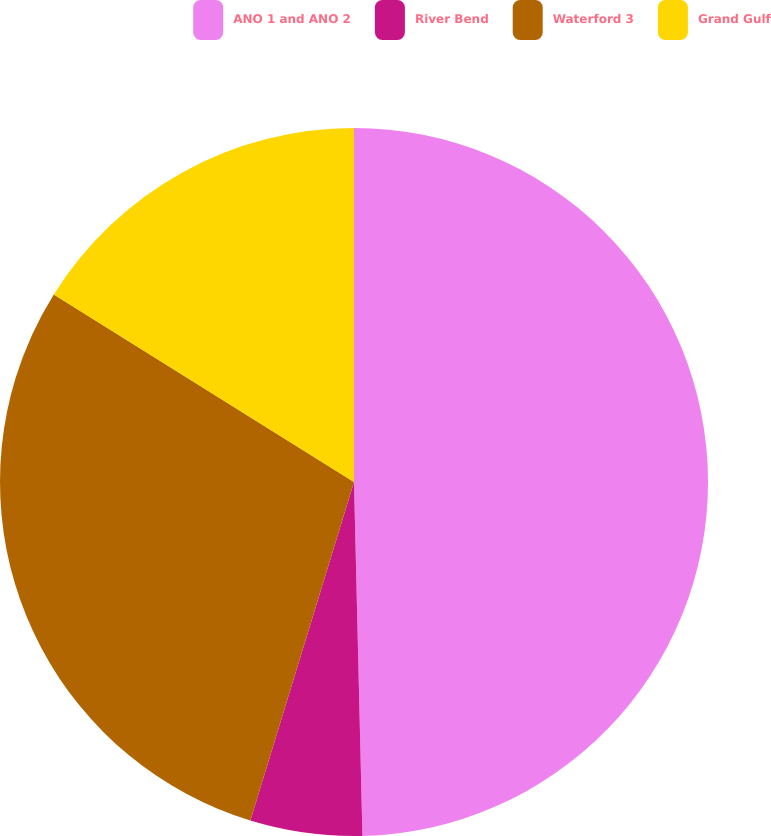<chart> <loc_0><loc_0><loc_500><loc_500><pie_chart><fcel>ANO 1 and ANO 2<fcel>River Bend<fcel>Waterford 3<fcel>Grand Gulf<nl><fcel>49.62%<fcel>5.11%<fcel>29.16%<fcel>16.11%<nl></chart> 